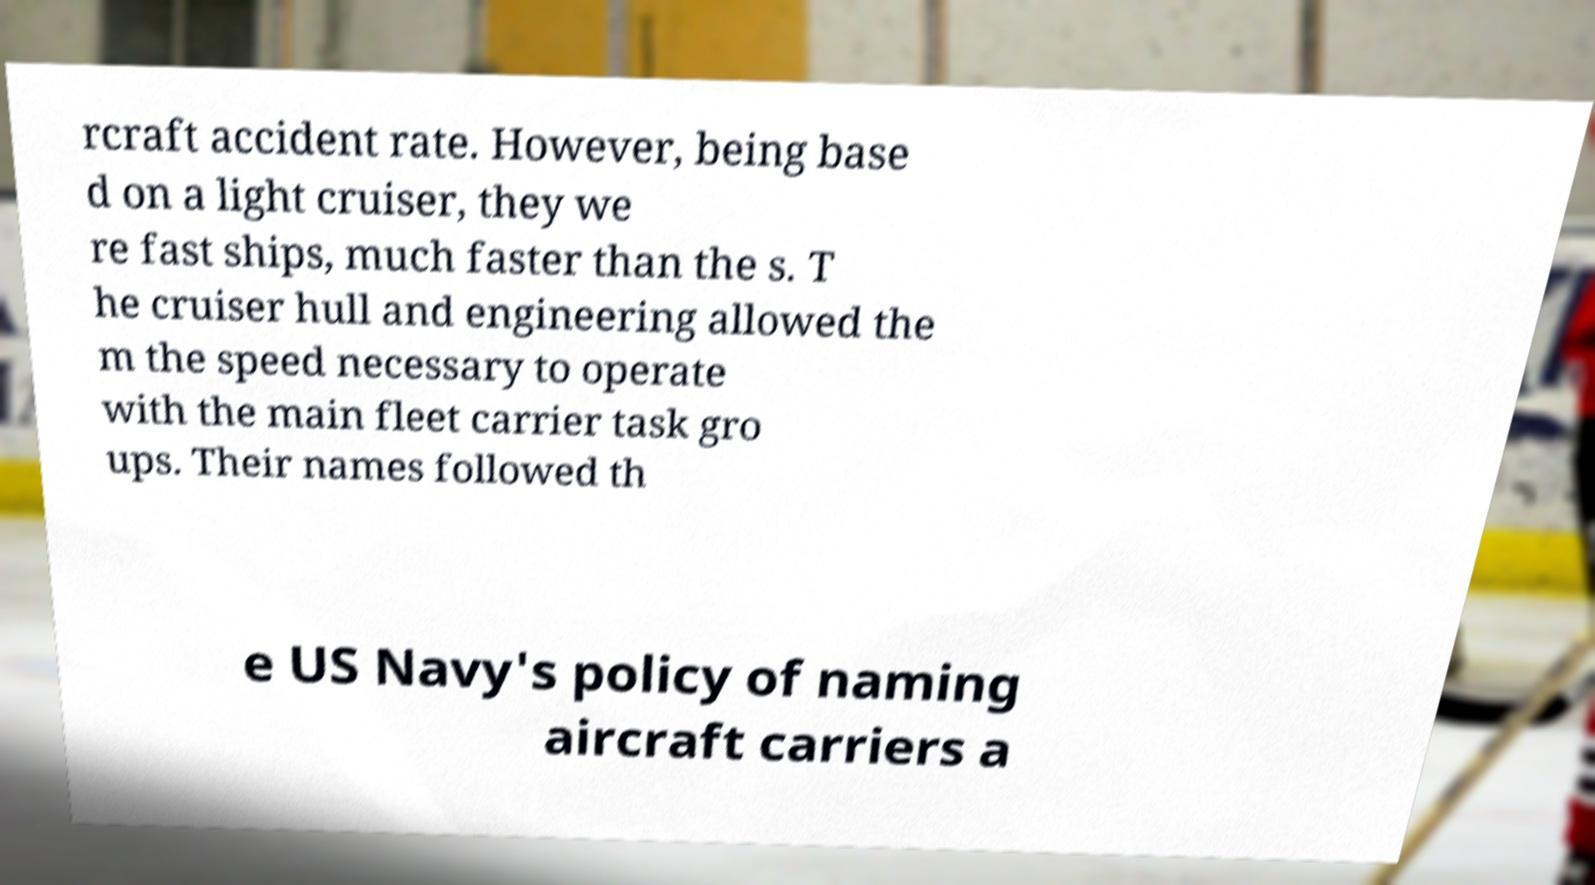Please read and relay the text visible in this image. What does it say? rcraft accident rate. However, being base d on a light cruiser, they we re fast ships, much faster than the s. T he cruiser hull and engineering allowed the m the speed necessary to operate with the main fleet carrier task gro ups. Their names followed th e US Navy's policy of naming aircraft carriers a 